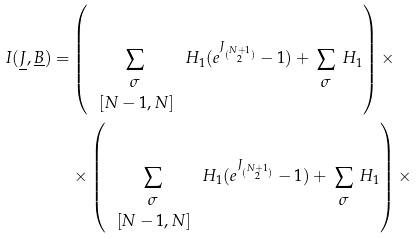Convert formula to latex. <formula><loc_0><loc_0><loc_500><loc_500>I ( \underline { J } , \underline { B } ) = & \left ( \sum _ { \begin{array} { c } \sigma \\ \, [ N - 1 , N ] \end{array} } H _ { 1 } ( e ^ { J _ { \binom { N + 1 } { 2 } } } - 1 ) + \sum _ { \begin{array} { c } \sigma \end{array} } H _ { 1 } \right ) \times \\ & \times \left ( \sum _ { \begin{array} { c } \sigma \\ \, [ N - 1 , N ] \end{array} } H _ { 1 } ( e ^ { J _ { \binom { N + 1 } { 2 } } } - 1 ) + \sum _ { \begin{array} { c } \sigma \end{array} } H _ { 1 } \right ) \times</formula> 